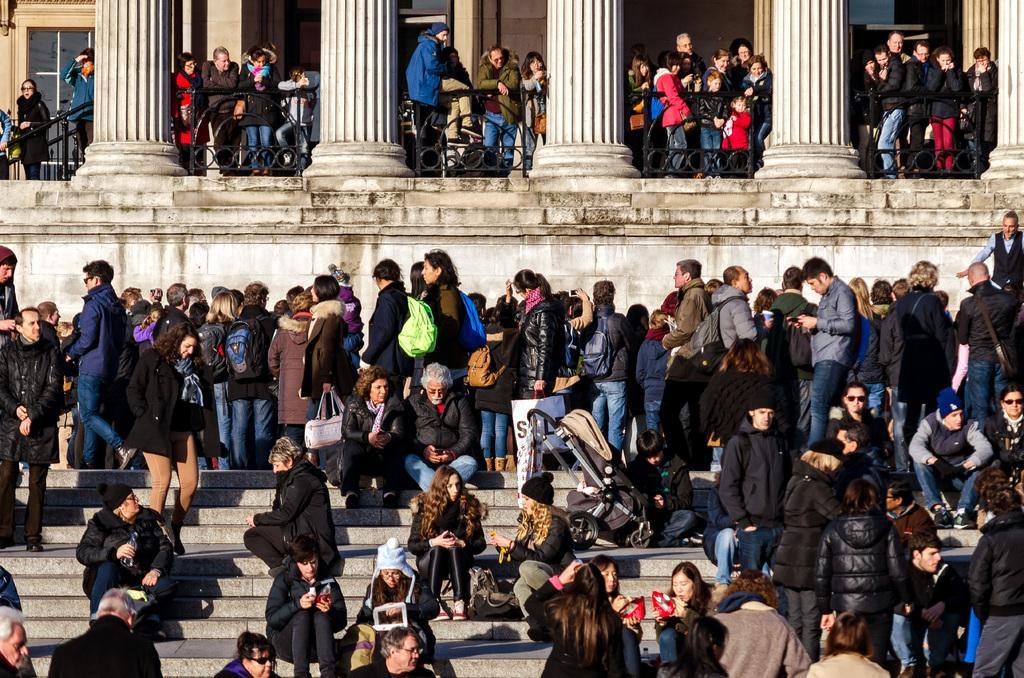How would you summarize this image in a sentence or two? In this picture I can observe some people. There are men and women in this picture. I can observe some children on the right side. Some of them are sitting on the steps and some of them are standing. There are four pillars on the top of the picture. In the background there is a building. 